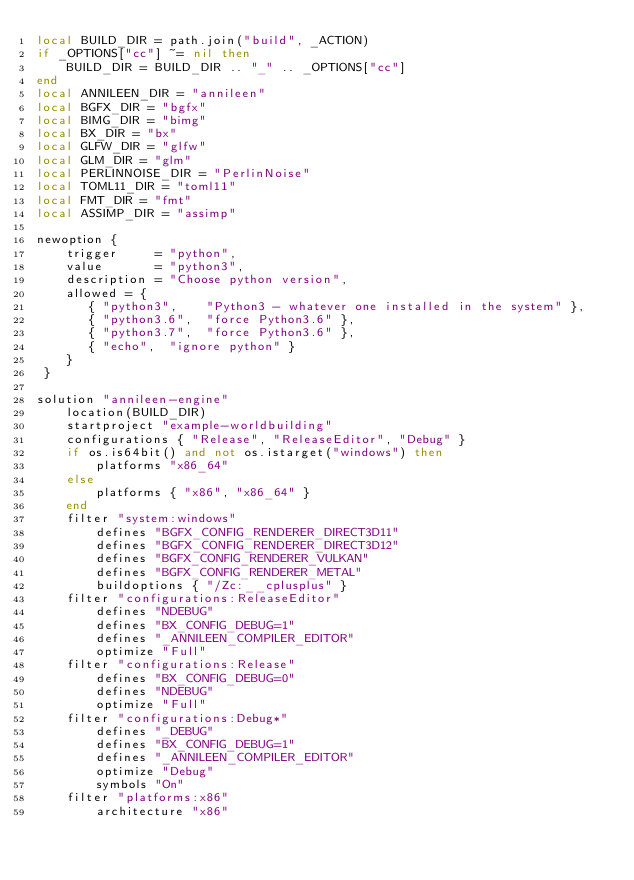Convert code to text. <code><loc_0><loc_0><loc_500><loc_500><_Lua_>local BUILD_DIR = path.join("build", _ACTION)
if _OPTIONS["cc"] ~= nil then
	BUILD_DIR = BUILD_DIR .. "_" .. _OPTIONS["cc"]
end
local ANNILEEN_DIR = "annileen"
local BGFX_DIR = "bgfx"
local BIMG_DIR = "bimg"
local BX_DIR = "bx"
local GLFW_DIR = "glfw"
local GLM_DIR = "glm"
local PERLINNOISE_DIR = "PerlinNoise"
local TOML11_DIR = "toml11"
local FMT_DIR = "fmt"
local ASSIMP_DIR = "assimp"

newoption {
	trigger     = "python",
	value       = "python3",
	description = "Choose python version",
	allowed = {
	   { "python3",    "Python3 - whatever one installed in the system" },
	   { "python3.6",  "force Python3.6" },
	   { "python3.7",  "force Python3.6" },
	   { "echo",  "ignore python" }
	}
 }

solution "annileen-engine"
	location(BUILD_DIR)
	startproject "example-worldbuilding"
	configurations { "Release", "ReleaseEditor", "Debug" }
	if os.is64bit() and not os.istarget("windows") then
		platforms "x86_64"
	else
		platforms { "x86", "x86_64" }
	end
	filter "system:windows"
		defines "BGFX_CONFIG_RENDERER_DIRECT3D11"
		defines "BGFX_CONFIG_RENDERER_DIRECT3D12"
		defines "BGFX_CONFIG_RENDERER_VULKAN"
		defines "BGFX_CONFIG_RENDERER_METAL"
		buildoptions { "/Zc:__cplusplus" }
	filter "configurations:ReleaseEditor"
		defines "NDEBUG"
		defines "BX_CONFIG_DEBUG=1"
		defines "_ANNILEEN_COMPILER_EDITOR"
		optimize "Full"
	filter "configurations:Release"
		defines "BX_CONFIG_DEBUG=0"
		defines "NDEBUG"
		optimize "Full"
	filter "configurations:Debug*"
		defines "_DEBUG"
		defines "BX_CONFIG_DEBUG=1"
		defines "_ANNILEEN_COMPILER_EDITOR"
		optimize "Debug"
		symbols "On"
	filter "platforms:x86"
		architecture "x86"</code> 